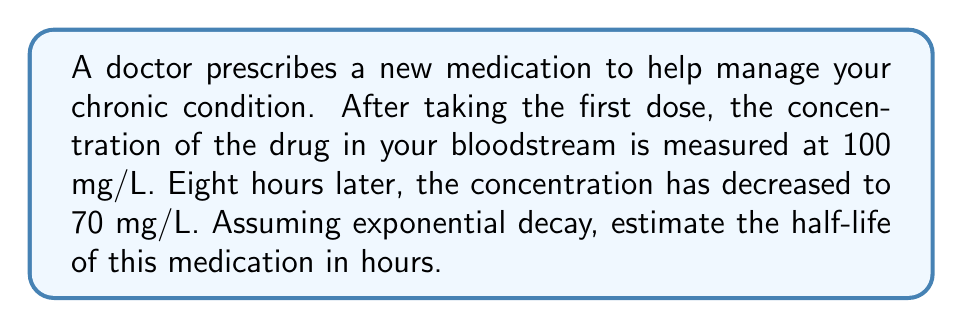Teach me how to tackle this problem. Let's approach this step-by-step:

1) The exponential decay formula is:
   $$C(t) = C_0 e^{-kt}$$
   where $C(t)$ is the concentration at time $t$, $C_0$ is the initial concentration, $k$ is the decay constant, and $t$ is time.

2) We know:
   $C_0 = 100$ mg/L
   $C(8) = 70$ mg/L
   $t = 8$ hours

3) Substituting these values into the formula:
   $$70 = 100 e^{-8k}$$

4) Dividing both sides by 100:
   $$0.7 = e^{-8k}$$

5) Taking the natural log of both sides:
   $$\ln(0.7) = -8k$$

6) Solving for $k$:
   $$k = -\frac{\ln(0.7)}{8} \approx 0.0446$$

7) The half-life $t_{1/2}$ is related to $k$ by:
   $$t_{1/2} = \frac{\ln(2)}{k}$$

8) Substituting our value for $k$:
   $$t_{1/2} = \frac{\ln(2)}{0.0446} \approx 15.54$$ hours

Therefore, the estimated half-life of the medication is approximately 15.54 hours.
Answer: 15.54 hours 